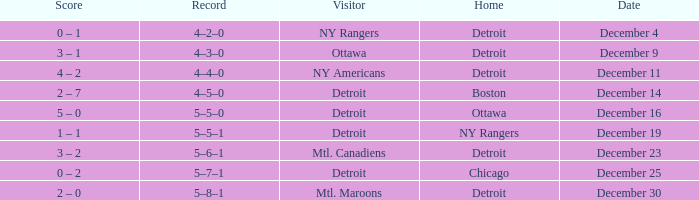What record has detroit as the home and mtl. maroons as the visitor? 5–8–1. 